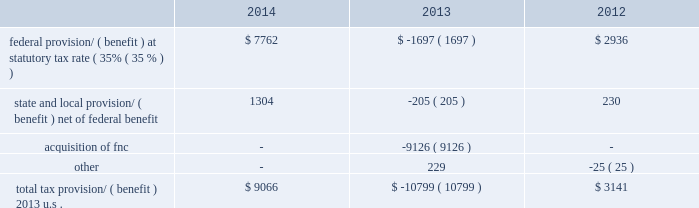Kimco realty corporation and subsidiaries notes to consolidated financial statements , continued the company 2019s investments in latin america are made through individual entities which are subject to local taxes .
The company assesses each entity to determine if deferred tax assets are more likely than not realizable .
This assessment primarily includes an analysis of cumulative earnings and the determination of future earnings to the extent necessary to fully realize the individual deferred tax asset .
Based on this analysis the company has determined that a full valuation allowance is required for entities which have a three-year cumulative book loss and for which future earnings are not readily determinable .
In addition , the company has determined that no valuation allowance is needed for entities that have three-years of cumulative book income and future earnings are anticipated to be sufficient to more likely than not realize their deferred tax assets .
At december 31 , 2014 , the company had total deferred tax assets of $ 9.5 million relating to its latin american investments with an aggregate valuation allowance of $ 9.3 million .
The company 2019s deferred tax assets in canada result principally from depreciation deducted under gaap that exceed capital cost allowances claimed under canadian tax rules .
The deferred tax asset will naturally reverse upon disposition as tax basis will be greater than the basis of the assets under generally accepted accounting principles .
As of december 31 , 2014 , the company determined that no valuation allowance was needed against a $ 65.5 million net deferred tax asset within krs .
The company based its determination on an analysis of both positive evidence and negative evidence using its judgment as to the relative weight of each .
The company believes , when evaluating krs 2019s deferred tax assets , special consideration should be given to the unique relationship between the company as a reit and krs as a taxable reit subsidiary .
This relationship exists primarily to protect the reit 2019s qualification under the code by permitting , within certain limits , the reit to engage in certain business activities in which the reit cannot directly participate .
As such , the reit controls which and when investments are held in , or distributed or sold from , krs .
This relationship distinguishes a reit and taxable reit subsidiary from an enterprise that operates as a single , consolidated corporate taxpayer .
The company will continue through this structure to operate certain business activities in krs .
The company 2019s analysis of krs 2019s ability to utilize its deferred tax assets includes an estimate of future projected income .
To determine future projected income , the company scheduled krs 2019s pre-tax book income and taxable income over a twenty year period taking into account its continuing operations ( 201ccore earnings 201d ) .
Core earnings consist of estimated net operating income for properties currently in service and generating rental income .
Major lease turnover is not expected in these properties as these properties were generally constructed and leased within the past seven years .
The company can employ strategies to realize krs 2019s deferred tax assets including transferring its property management business or selling certain built-in gain assets .
The company 2019s projection of krs 2019s future taxable income over twenty years , utilizing the assumptions above with respect to core earnings , net of related expenses , generates sufficient taxable income to absorb a reversal of the company 2019s deductible temporary differences , including net operating loss carryovers .
Based on this analysis , the company concluded it is more likely than not that krs 2019s net deferred tax asset of $ 65.5 million ( excluding net deferred tax assets of fnc discussed above ) will be realized and therefore , no valuation allowance is needed at december 31 , 2014 .
If future income projections do not occur as forecasted or the company incurs additional impairment losses in excess of the amount core earnings can absorb , the company will reconsider the need for a valuation allowance .
Provision/ ( benefit ) differ from the amounts computed by applying the statutory federal income tax rate to taxable income before income taxes as follows ( in thousands ) : .

What percentage of the total tax benefits came from the acquisition of fnc? 
Computations: (9126 / 10799)
Answer: 0.84508. 